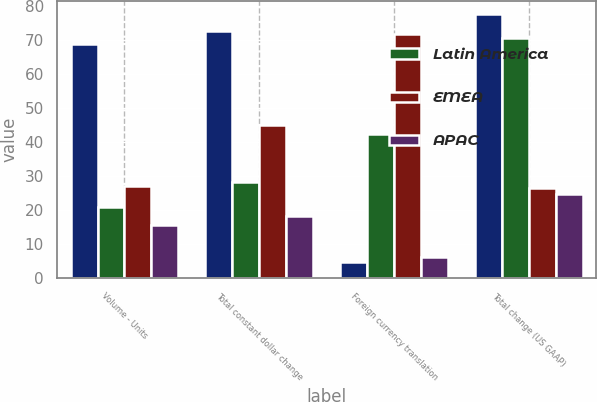Convert chart to OTSL. <chart><loc_0><loc_0><loc_500><loc_500><stacked_bar_chart><ecel><fcel>Volume - Units<fcel>Total constant dollar change<fcel>Foreign currency translation<fcel>Total change (US GAAP)<nl><fcel>nan<fcel>68.8<fcel>72.6<fcel>4.9<fcel>77.5<nl><fcel>Latin America<fcel>20.8<fcel>28.2<fcel>42.2<fcel>70.4<nl><fcel>EMEA<fcel>27.1<fcel>45.1<fcel>71.6<fcel>26.5<nl><fcel>APAC<fcel>15.7<fcel>18.4<fcel>6.2<fcel>24.6<nl></chart> 